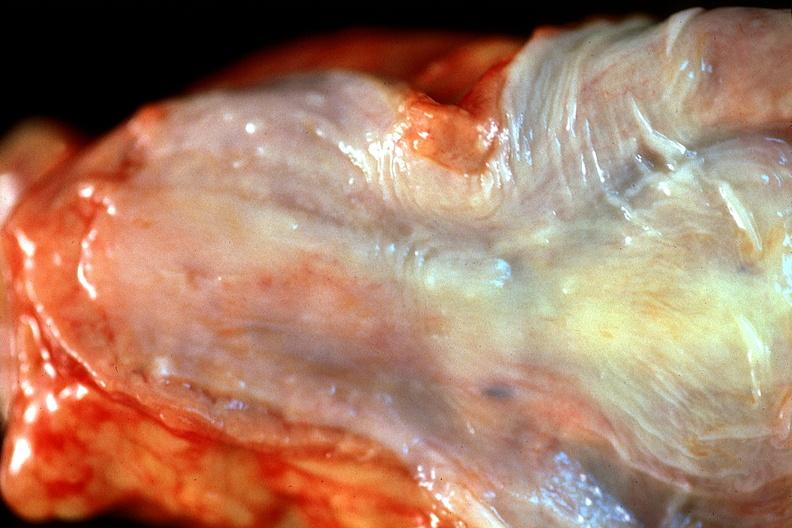does gastrointestinal show normal esophagus?
Answer the question using a single word or phrase. No 